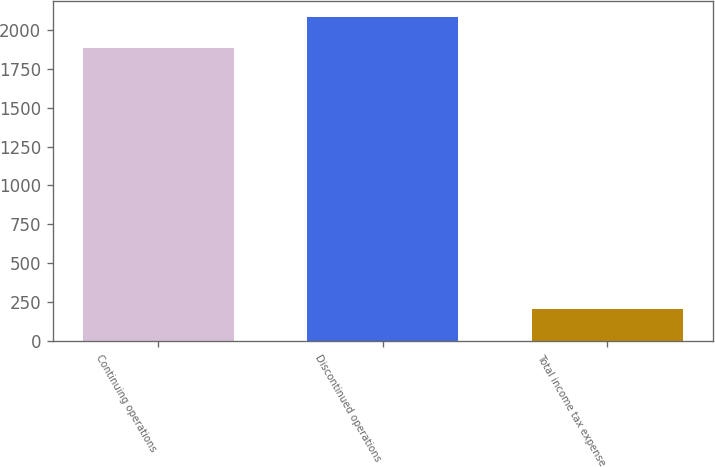Convert chart to OTSL. <chart><loc_0><loc_0><loc_500><loc_500><bar_chart><fcel>Continuing operations<fcel>Discontinued operations<fcel>Total income tax expense<nl><fcel>1883<fcel>2085<fcel>202<nl></chart> 